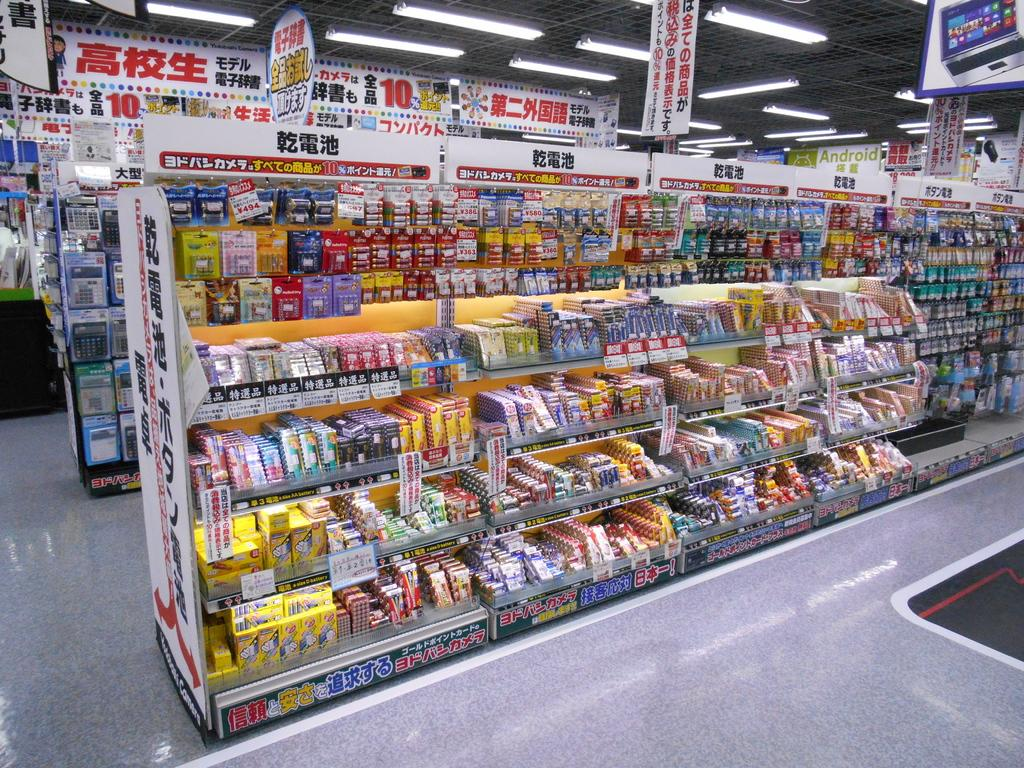What is the setting of the image? The image is set in the aisle of a supermarket. How many kittens are walking down the aisle in the image? There are no kittens present in the image; it is set in the aisle of a supermarket. 